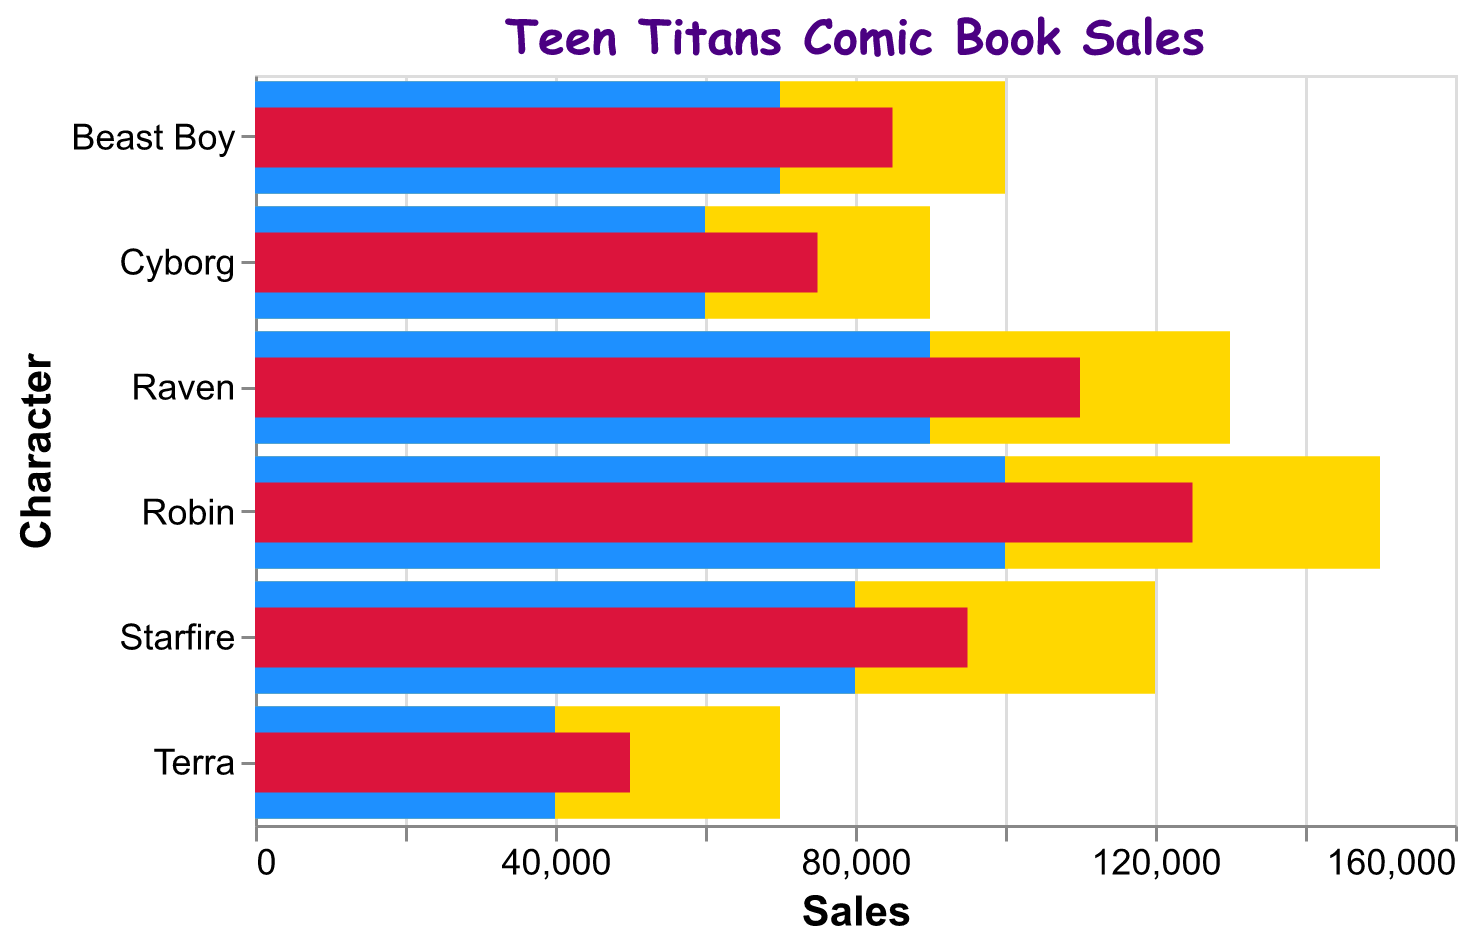What's the title of the chart? The title text is displayed at the top of the chart. By looking at the chart, we can see it reads "Teen Titans Comic Book Sales".
Answer: Teen Titans Comic Book Sales How many characters are displayed in this chart? Look at the y-axis; it lists the names of the characters. Counting the names, we can see there are six characters.
Answer: Six Which Teen Titan character has the highest actual sales? Referring to the red bars in the chart, the tallest red bar corresponds to Robin.
Answer: Robin What's the difference between the top sales and average sales for Cyborg? Locate Cyborg's data. Subtract the average sales value (60,000) from the top sales value (90,000): 90,000 - 60,000 = 30,000.
Answer: 30,000 What is the actual sales value of Raven? The red bar representing Raven's actual sales can be hovered over to show 110,000.
Answer: 110,000 Compare the actual sales of Beast Boy and Starfire. Who sold more? Compare the lengths of the red bars for Beast Boy (85,000) and Starfire (95,000). Starfire sold more.
Answer: Starfire Which character has the lowest average sales? By examining the blue bars, Terra has the lowest average sales on the y-axis, which is listed as 40,000.
Answer: Terra What is the range of actual sales among all characters listed? To find the range, subtract the smallest actual sales from the largest actual sales. Robin has the highest actual sales (125,000), and Terra has the lowest (50,000). Range: 125,000 - 50,000 = 75,000.
Answer: 75,000 How do the average sales of Starfire and Raven compare to each other? Comparing the blue bars for Starfire and Raven, Starfire's average sales are 80,000 and Raven's are 90,000. Raven's average sales are higher than Starfire's.
Answer: Raven's average sales are higher What is the combined total of actual sales for Beast Boy and Cyborg? Sum up the actual sales data for Beast Boy and Cyborg. Beast Boy has 85,000 sales and Cyborg has 75,000 sales. Therefore, 85,000 + 75,000 = 160,000.
Answer: 160,000 